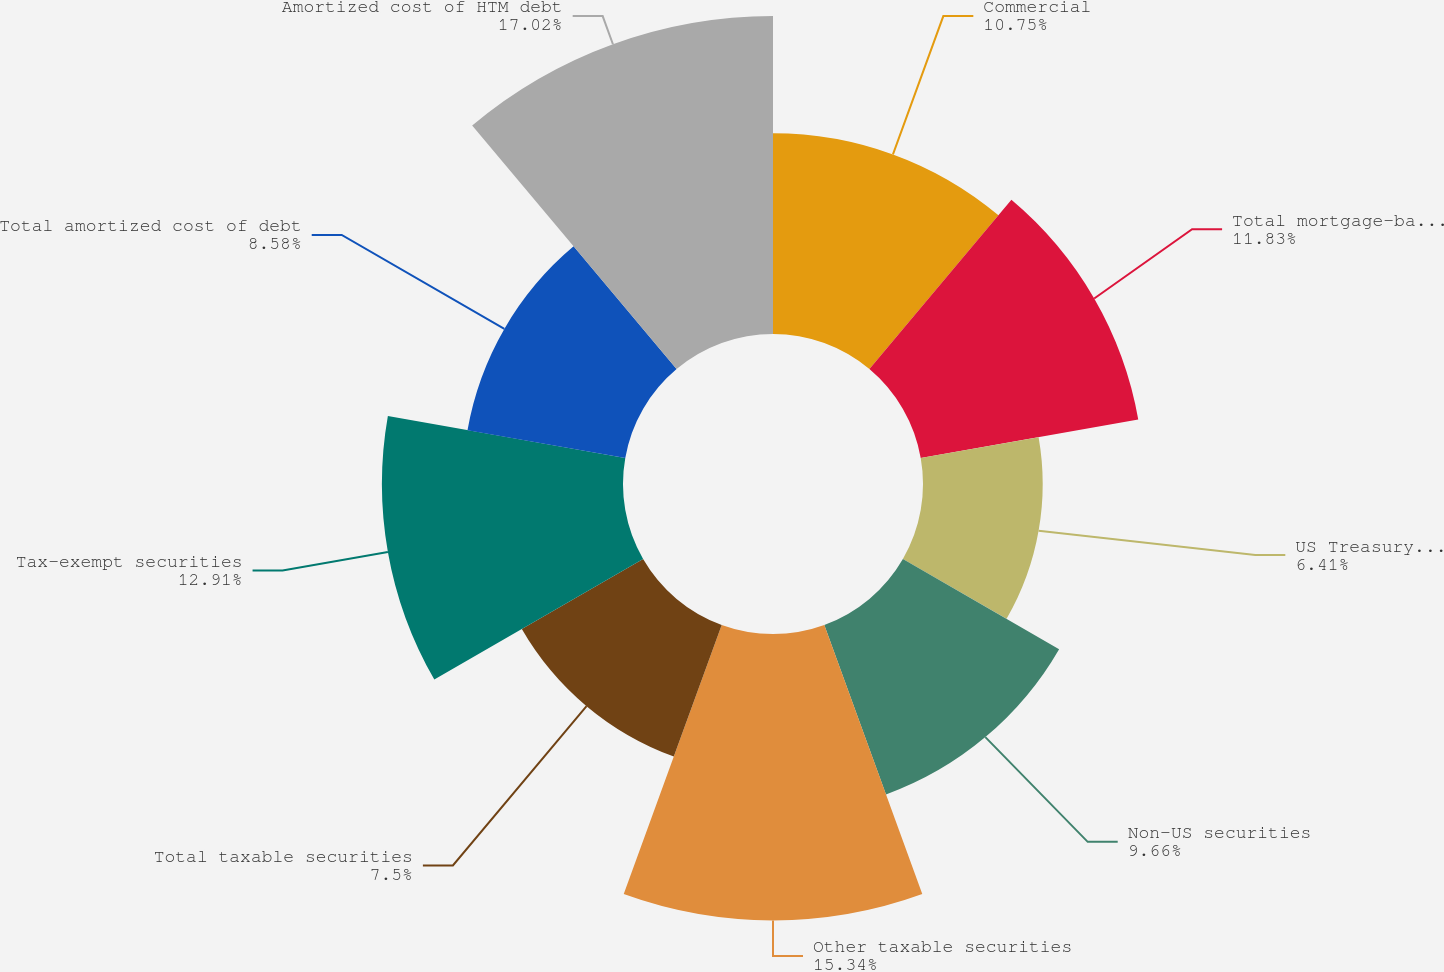Convert chart. <chart><loc_0><loc_0><loc_500><loc_500><pie_chart><fcel>Commercial<fcel>Total mortgage-backed<fcel>US Treasury and agency<fcel>Non-US securities<fcel>Other taxable securities<fcel>Total taxable securities<fcel>Tax-exempt securities<fcel>Total amortized cost of debt<fcel>Amortized cost of HTM debt<nl><fcel>10.75%<fcel>11.83%<fcel>6.41%<fcel>9.66%<fcel>15.34%<fcel>7.5%<fcel>12.91%<fcel>8.58%<fcel>17.03%<nl></chart> 